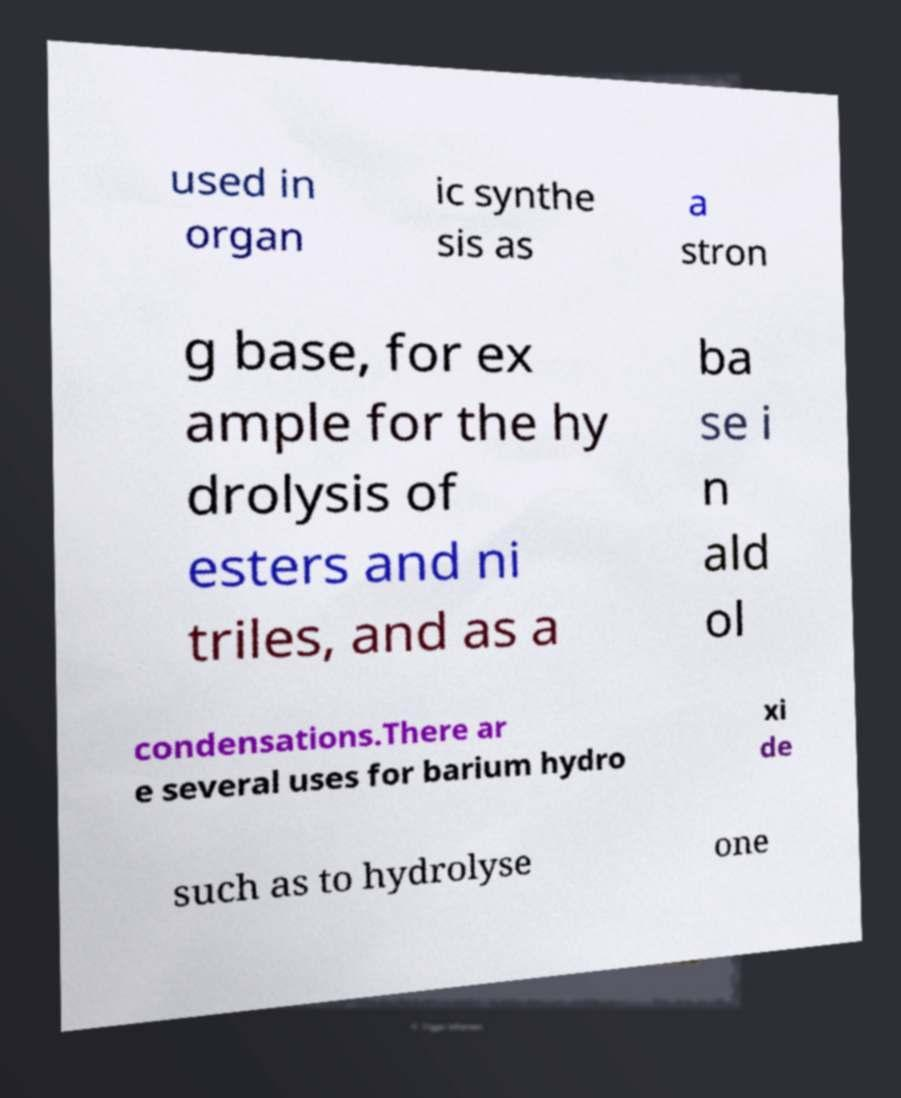I need the written content from this picture converted into text. Can you do that? used in organ ic synthe sis as a stron g base, for ex ample for the hy drolysis of esters and ni triles, and as a ba se i n ald ol condensations.There ar e several uses for barium hydro xi de such as to hydrolyse one 